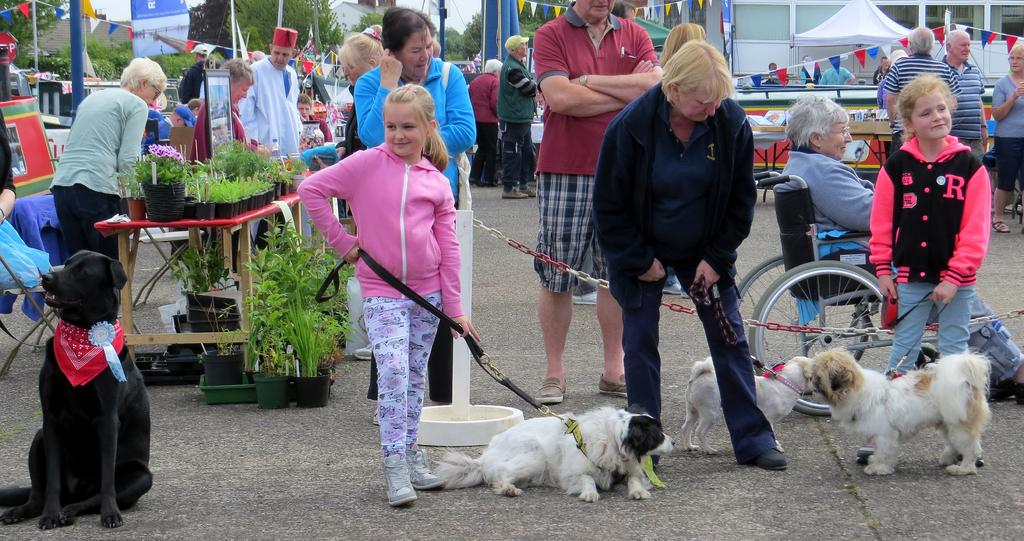Who or what can be seen in the image? There are people, dogs, and plants in the image. What objects are present in the image? A wheelchair, a table, and buildings are present in the image. What type of natural elements can be seen in the image? Trees and the sky are visible in the image. What type of books can be seen on the dogs in the image? There are no books present in the image, and the dogs are not carrying any books. 